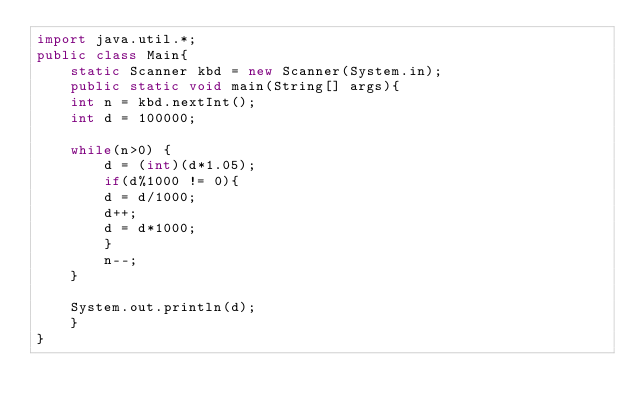<code> <loc_0><loc_0><loc_500><loc_500><_Java_>import java.util.*;
public class Main{
    static Scanner kbd = new Scanner(System.in);
    public static void main(String[] args){
	int n = kbd.nextInt();
	int d = 100000;

	while(n>0) {
	    d = (int)(d*1.05);
	    if(d%1000 != 0){
		d = d/1000;
		d++;
		d = d*1000;
	    }
	    n--;
	}

	System.out.println(d);
    }   
}</code> 